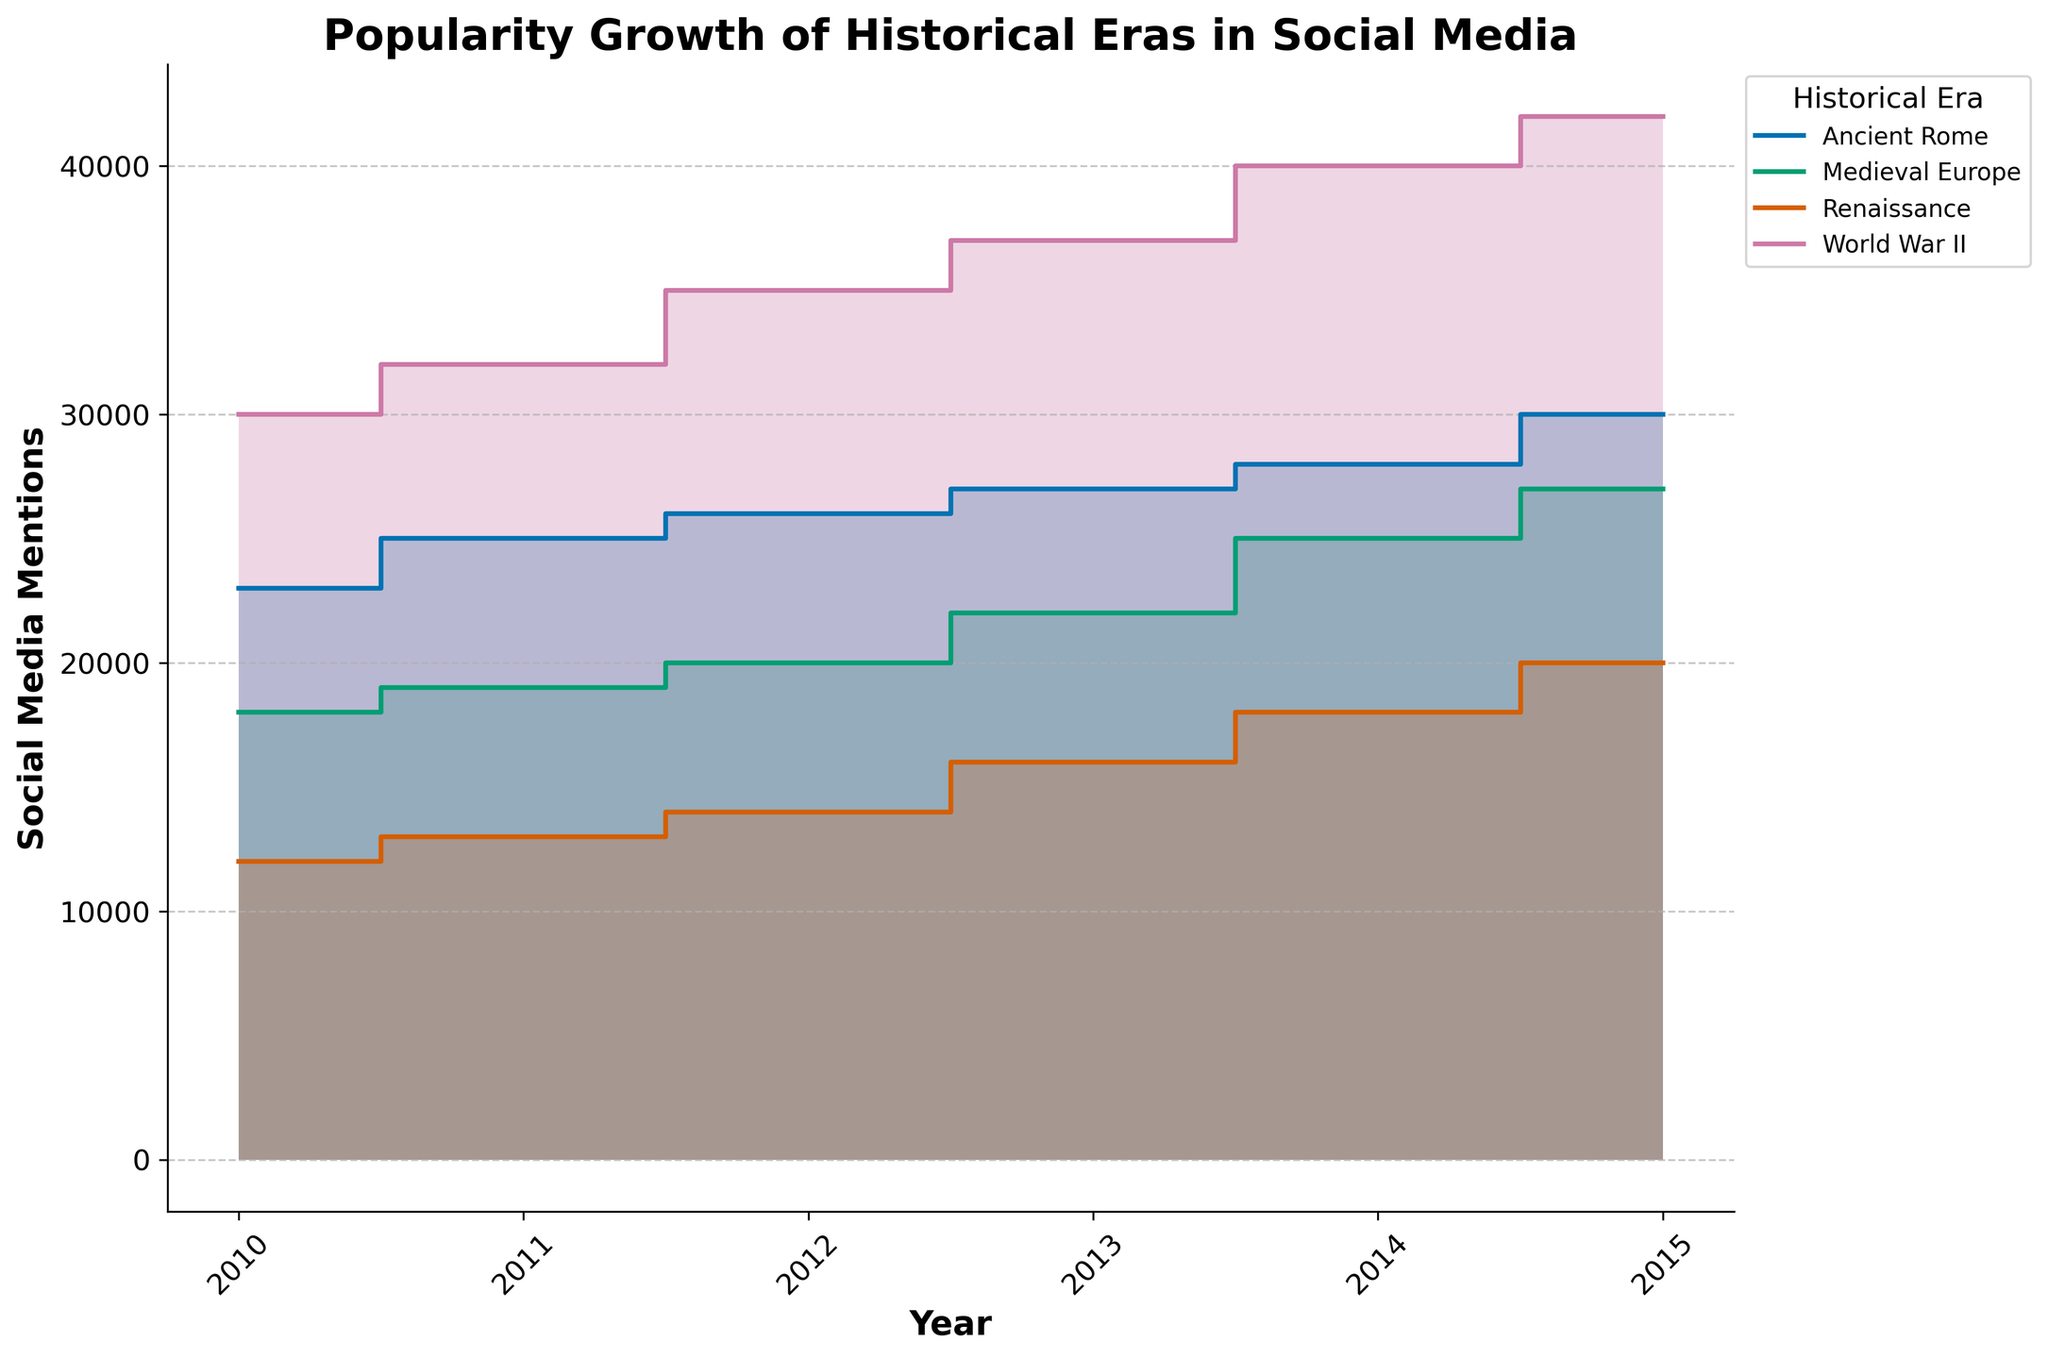Which era has the highest peak in social media mentions? Look for the era with the highest point on the y-axis. World War II has the highest peak on the chart, as its mentions reach above 40,000.
Answer: World War II What year did Medieval Europe see a significant increase in social media mentions, reaching over 20,000? Identify the year when the Medieval Europe line rises above the 20,000 mentions mark. The chart shows this increase between 2013 and 2014.
Answer: 2014 How do social media mentions of Ancient Rome in 2015 compare to those of Medieval Europe in the same year? Compare the heights of the lines for Ancient Rome and Medieval Europe in 2015. Ancient Rome's mentions are at 30,000, while Medieval Europe's are at 27,000.
Answer: Ancient Rome has more mentions Which era shows a consistent increase in social media mentions every year? Look for a line that rises steadily without dips or plateaus. World War II shows a consistently increasing trend.
Answer: World War II In which year did Renaissance social media mentions first exceed 15,000? Examine the Renaissance line to find the first year it surpasses 15,000 mentions. This occurs between 2012 and 2013.
Answer: 2013 What is the difference in social media mentions between Ancient Rome and Renaissance in 2015? Find the mention counts for both eras in 2015 and subtract the Renaissance mentions from the Ancient Rome mentions. Ancient Rome has 30,000 mentions, and Renaissance has 20,000, so the difference is 30,000 - 20,000 = 10,000.
Answer: 10,000 How do the social media mentions trends of Ancient Rome and World War II compare from 2010 to 2015? Compare the slope and overall trend of the lines for Ancient Rome and World War II. Both increase over time, but World War II has a steeper increase, especially from 2012 to 2015.
Answer: World War II has a steeper increase Which historical era had the least social media mentions in 2010? Identify the era with the lowest point on the y-axis for the year 2010. The Renaissance has the fewest mentions at 12,000.
Answer: Renaissance What is the total increase in social media mentions for World War II from 2010 to 2015? Subtract the mentions in 2010 from the mentions in 2015 for World War II. The increase is 42,000 - 30,000 = 12,000.
Answer: 12,000 Compare the pace of growth in social media mentions for Medieval Europe and Renaissance from 2010 to 2015. Which grew faster? Evaluate the steepness of the increase for both lines over the given years. Medieval Europe shows a more rapid increase compared to Renaissance, especially after 2013.
Answer: Medieval Europe grew faster 